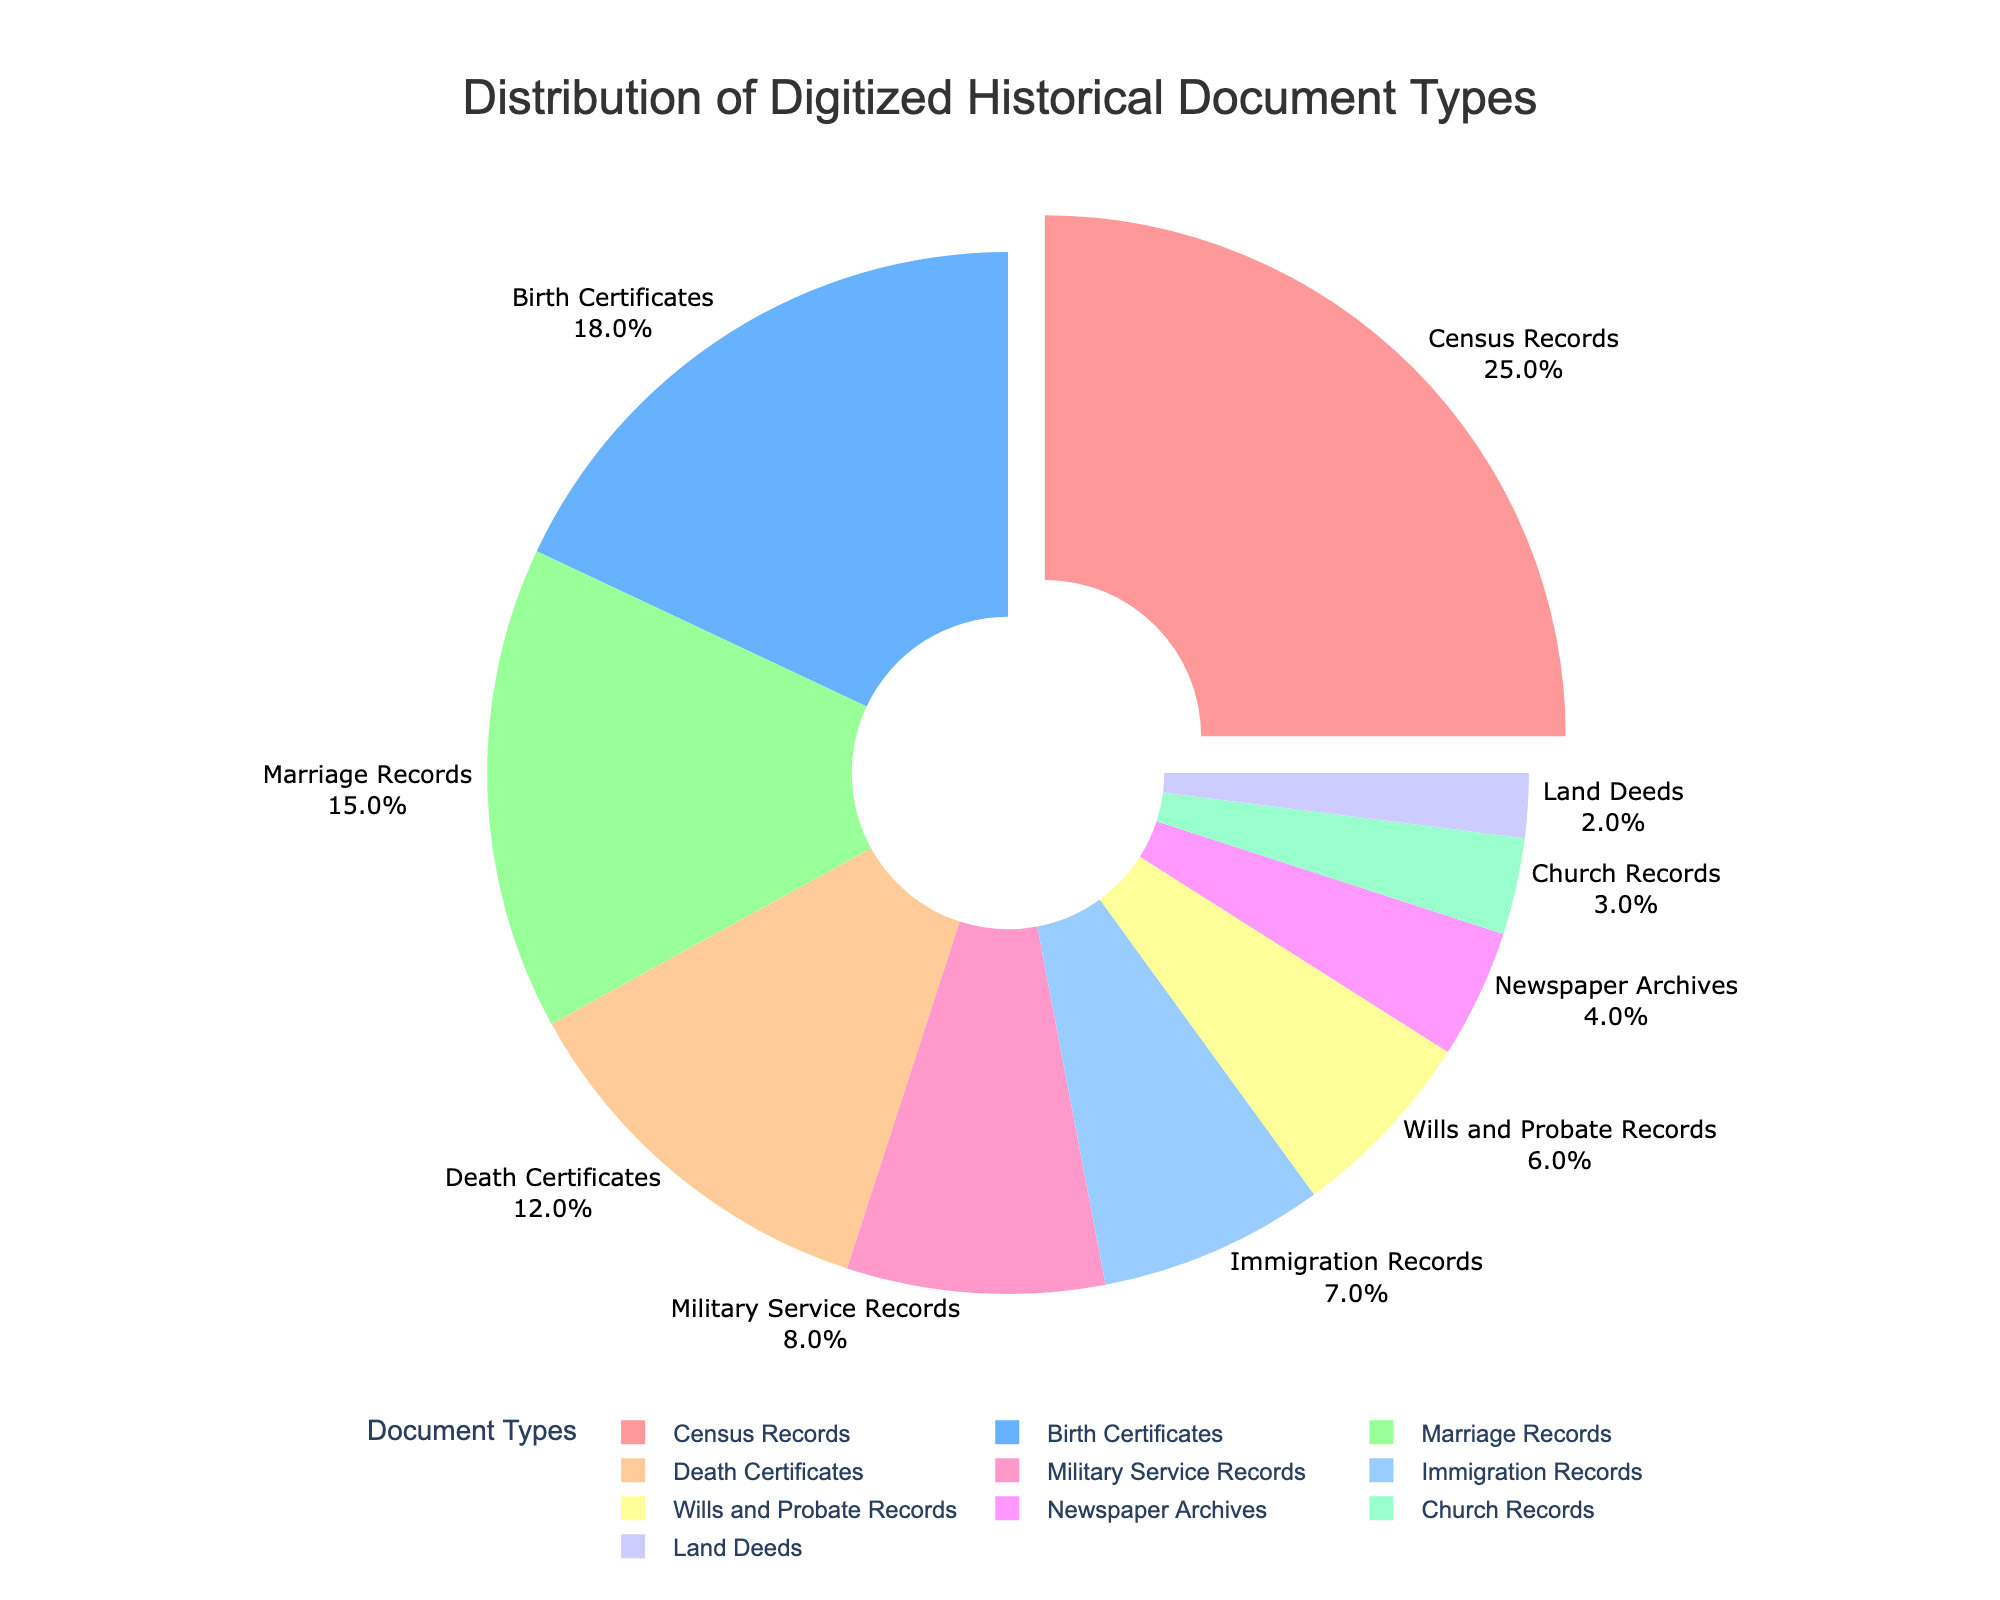What percentage of the digitized historical documents are Birth Certificates and Marriage Records combined? To find the combined percentage, add the percentages of Birth Certificates (18%) and Marriage Records (15%): 18% + 15% = 33%.
Answer: 33% Which document type has the largest representation in the pie chart? Identify the document type with the largest percentage value in the chart. The largest percentage is 25% for Census Records.
Answer: Census Records How does the percentage of Death Certificates compare to that of Military Service Records? Compare the given percentages for Death Certificates (12%) and Military Service Records (8%): 12% is greater than 8%.
Answer: Greater What is the percentage difference between Census Records and Birth Certificates? Subtract the percentage of Birth Certificates (18%) from that of Census Records (25%): 25% - 18% = 7%.
Answer: 7% What portion of the documents is represented by Immigration Records, Church Records, and Land Deeds combined? Sum the percentages of Immigration Records (7%), Church Records (3%), and Land Deeds (2%): 7% + 3% + 2% = 12%.
Answer: 12% Which document type has the smallest representation, and what is its percentage? Identify the document type with the smallest percentage. Land Deeds have the smallest percentage (2%).
Answer: Land Deeds, 2% What percentage of the documents are Census Records, Birth Certificates, and Marriage Records together? Sum the percentages of Census Records (25%), Birth Certificates (18%), and Marriage Records (15%): 25% + 18% + 15% = 58%.
Answer: 58% Are there more Census Records or Military Service Records, and by how much? Subtract the percentage of Military Service Records (8%) from Census Records (25%): 25% - 8% = 17%.
Answer: More by 17% What is the second most represented document type in the pie chart? Identify the document type with the second highest percentage. Birth Certificates, with 18%, are the second most represented.
Answer: Birth Certificates Compare the combined percentage of Wills and Probate Records and Newspaper Archives versus the percentage of Census Records. Add the percentages of Wills and Probate Records (6%) and Newspaper Archives (4%) to get 10%, which is less than the 25% for Census Records.
Answer: Less, combined is 10% 